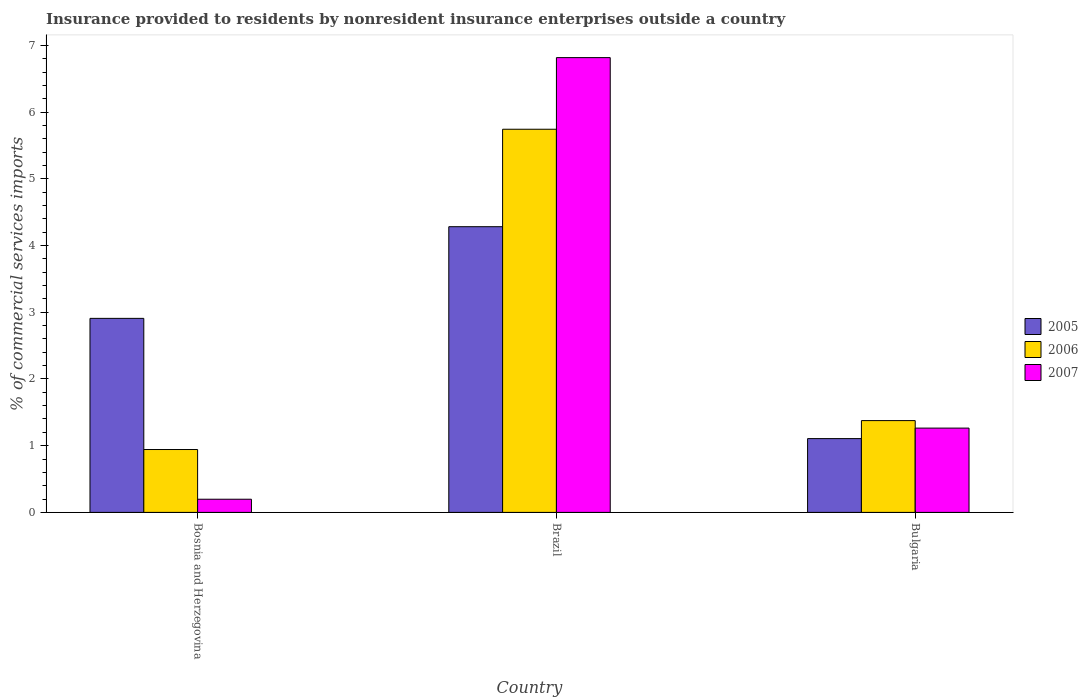How many different coloured bars are there?
Provide a succinct answer. 3. How many groups of bars are there?
Provide a succinct answer. 3. Are the number of bars on each tick of the X-axis equal?
Provide a short and direct response. Yes. How many bars are there on the 1st tick from the left?
Your answer should be very brief. 3. How many bars are there on the 3rd tick from the right?
Give a very brief answer. 3. What is the label of the 1st group of bars from the left?
Offer a terse response. Bosnia and Herzegovina. What is the Insurance provided to residents in 2005 in Brazil?
Offer a very short reply. 4.28. Across all countries, what is the maximum Insurance provided to residents in 2007?
Ensure brevity in your answer.  6.82. Across all countries, what is the minimum Insurance provided to residents in 2006?
Your response must be concise. 0.94. In which country was the Insurance provided to residents in 2005 minimum?
Offer a very short reply. Bulgaria. What is the total Insurance provided to residents in 2007 in the graph?
Offer a very short reply. 8.28. What is the difference between the Insurance provided to residents in 2005 in Brazil and that in Bulgaria?
Your response must be concise. 3.18. What is the difference between the Insurance provided to residents in 2006 in Bulgaria and the Insurance provided to residents in 2005 in Brazil?
Offer a terse response. -2.91. What is the average Insurance provided to residents in 2005 per country?
Keep it short and to the point. 2.77. What is the difference between the Insurance provided to residents of/in 2005 and Insurance provided to residents of/in 2007 in Bulgaria?
Your answer should be very brief. -0.16. In how many countries, is the Insurance provided to residents in 2006 greater than 0.4 %?
Keep it short and to the point. 3. What is the ratio of the Insurance provided to residents in 2006 in Bosnia and Herzegovina to that in Bulgaria?
Provide a succinct answer. 0.68. Is the difference between the Insurance provided to residents in 2005 in Bosnia and Herzegovina and Brazil greater than the difference between the Insurance provided to residents in 2007 in Bosnia and Herzegovina and Brazil?
Keep it short and to the point. Yes. What is the difference between the highest and the second highest Insurance provided to residents in 2005?
Offer a very short reply. -1.8. What is the difference between the highest and the lowest Insurance provided to residents in 2007?
Ensure brevity in your answer.  6.62. Is the sum of the Insurance provided to residents in 2007 in Bosnia and Herzegovina and Brazil greater than the maximum Insurance provided to residents in 2006 across all countries?
Ensure brevity in your answer.  Yes. What does the 3rd bar from the left in Bosnia and Herzegovina represents?
Your response must be concise. 2007. What does the 1st bar from the right in Bosnia and Herzegovina represents?
Your answer should be very brief. 2007. Is it the case that in every country, the sum of the Insurance provided to residents in 2005 and Insurance provided to residents in 2007 is greater than the Insurance provided to residents in 2006?
Offer a terse response. Yes. How many bars are there?
Make the answer very short. 9. What is the difference between two consecutive major ticks on the Y-axis?
Your response must be concise. 1. Does the graph contain any zero values?
Keep it short and to the point. No. How many legend labels are there?
Provide a short and direct response. 3. How are the legend labels stacked?
Give a very brief answer. Vertical. What is the title of the graph?
Your response must be concise. Insurance provided to residents by nonresident insurance enterprises outside a country. What is the label or title of the Y-axis?
Your response must be concise. % of commercial services imports. What is the % of commercial services imports in 2005 in Bosnia and Herzegovina?
Keep it short and to the point. 2.91. What is the % of commercial services imports in 2006 in Bosnia and Herzegovina?
Give a very brief answer. 0.94. What is the % of commercial services imports in 2007 in Bosnia and Herzegovina?
Make the answer very short. 0.2. What is the % of commercial services imports in 2005 in Brazil?
Your answer should be compact. 4.28. What is the % of commercial services imports in 2006 in Brazil?
Give a very brief answer. 5.74. What is the % of commercial services imports of 2007 in Brazil?
Offer a very short reply. 6.82. What is the % of commercial services imports in 2005 in Bulgaria?
Keep it short and to the point. 1.11. What is the % of commercial services imports in 2006 in Bulgaria?
Ensure brevity in your answer.  1.38. What is the % of commercial services imports of 2007 in Bulgaria?
Provide a short and direct response. 1.26. Across all countries, what is the maximum % of commercial services imports in 2005?
Offer a very short reply. 4.28. Across all countries, what is the maximum % of commercial services imports of 2006?
Your response must be concise. 5.74. Across all countries, what is the maximum % of commercial services imports in 2007?
Keep it short and to the point. 6.82. Across all countries, what is the minimum % of commercial services imports of 2005?
Provide a succinct answer. 1.11. Across all countries, what is the minimum % of commercial services imports in 2006?
Offer a very short reply. 0.94. Across all countries, what is the minimum % of commercial services imports in 2007?
Provide a succinct answer. 0.2. What is the total % of commercial services imports of 2005 in the graph?
Ensure brevity in your answer.  8.3. What is the total % of commercial services imports of 2006 in the graph?
Make the answer very short. 8.06. What is the total % of commercial services imports in 2007 in the graph?
Provide a succinct answer. 8.28. What is the difference between the % of commercial services imports in 2005 in Bosnia and Herzegovina and that in Brazil?
Keep it short and to the point. -1.37. What is the difference between the % of commercial services imports of 2006 in Bosnia and Herzegovina and that in Brazil?
Provide a short and direct response. -4.8. What is the difference between the % of commercial services imports of 2007 in Bosnia and Herzegovina and that in Brazil?
Offer a terse response. -6.62. What is the difference between the % of commercial services imports of 2005 in Bosnia and Herzegovina and that in Bulgaria?
Your answer should be very brief. 1.8. What is the difference between the % of commercial services imports in 2006 in Bosnia and Herzegovina and that in Bulgaria?
Provide a succinct answer. -0.43. What is the difference between the % of commercial services imports in 2007 in Bosnia and Herzegovina and that in Bulgaria?
Offer a terse response. -1.07. What is the difference between the % of commercial services imports of 2005 in Brazil and that in Bulgaria?
Your answer should be compact. 3.18. What is the difference between the % of commercial services imports of 2006 in Brazil and that in Bulgaria?
Give a very brief answer. 4.37. What is the difference between the % of commercial services imports in 2007 in Brazil and that in Bulgaria?
Provide a short and direct response. 5.55. What is the difference between the % of commercial services imports in 2005 in Bosnia and Herzegovina and the % of commercial services imports in 2006 in Brazil?
Keep it short and to the point. -2.83. What is the difference between the % of commercial services imports in 2005 in Bosnia and Herzegovina and the % of commercial services imports in 2007 in Brazil?
Make the answer very short. -3.91. What is the difference between the % of commercial services imports of 2006 in Bosnia and Herzegovina and the % of commercial services imports of 2007 in Brazil?
Provide a short and direct response. -5.87. What is the difference between the % of commercial services imports in 2005 in Bosnia and Herzegovina and the % of commercial services imports in 2006 in Bulgaria?
Provide a short and direct response. 1.53. What is the difference between the % of commercial services imports in 2005 in Bosnia and Herzegovina and the % of commercial services imports in 2007 in Bulgaria?
Make the answer very short. 1.64. What is the difference between the % of commercial services imports in 2006 in Bosnia and Herzegovina and the % of commercial services imports in 2007 in Bulgaria?
Offer a terse response. -0.32. What is the difference between the % of commercial services imports in 2005 in Brazil and the % of commercial services imports in 2006 in Bulgaria?
Ensure brevity in your answer.  2.91. What is the difference between the % of commercial services imports of 2005 in Brazil and the % of commercial services imports of 2007 in Bulgaria?
Make the answer very short. 3.02. What is the difference between the % of commercial services imports in 2006 in Brazil and the % of commercial services imports in 2007 in Bulgaria?
Offer a terse response. 4.48. What is the average % of commercial services imports in 2005 per country?
Provide a short and direct response. 2.77. What is the average % of commercial services imports in 2006 per country?
Your response must be concise. 2.69. What is the average % of commercial services imports of 2007 per country?
Provide a succinct answer. 2.76. What is the difference between the % of commercial services imports of 2005 and % of commercial services imports of 2006 in Bosnia and Herzegovina?
Make the answer very short. 1.97. What is the difference between the % of commercial services imports of 2005 and % of commercial services imports of 2007 in Bosnia and Herzegovina?
Offer a very short reply. 2.71. What is the difference between the % of commercial services imports in 2006 and % of commercial services imports in 2007 in Bosnia and Herzegovina?
Your answer should be compact. 0.74. What is the difference between the % of commercial services imports in 2005 and % of commercial services imports in 2006 in Brazil?
Provide a succinct answer. -1.46. What is the difference between the % of commercial services imports of 2005 and % of commercial services imports of 2007 in Brazil?
Keep it short and to the point. -2.53. What is the difference between the % of commercial services imports of 2006 and % of commercial services imports of 2007 in Brazil?
Offer a terse response. -1.07. What is the difference between the % of commercial services imports of 2005 and % of commercial services imports of 2006 in Bulgaria?
Your answer should be compact. -0.27. What is the difference between the % of commercial services imports in 2005 and % of commercial services imports in 2007 in Bulgaria?
Offer a very short reply. -0.16. What is the difference between the % of commercial services imports in 2006 and % of commercial services imports in 2007 in Bulgaria?
Make the answer very short. 0.11. What is the ratio of the % of commercial services imports in 2005 in Bosnia and Herzegovina to that in Brazil?
Provide a short and direct response. 0.68. What is the ratio of the % of commercial services imports in 2006 in Bosnia and Herzegovina to that in Brazil?
Keep it short and to the point. 0.16. What is the ratio of the % of commercial services imports in 2007 in Bosnia and Herzegovina to that in Brazil?
Your answer should be compact. 0.03. What is the ratio of the % of commercial services imports of 2005 in Bosnia and Herzegovina to that in Bulgaria?
Provide a short and direct response. 2.63. What is the ratio of the % of commercial services imports in 2006 in Bosnia and Herzegovina to that in Bulgaria?
Your answer should be very brief. 0.68. What is the ratio of the % of commercial services imports in 2007 in Bosnia and Herzegovina to that in Bulgaria?
Provide a short and direct response. 0.16. What is the ratio of the % of commercial services imports in 2005 in Brazil to that in Bulgaria?
Make the answer very short. 3.87. What is the ratio of the % of commercial services imports in 2006 in Brazil to that in Bulgaria?
Keep it short and to the point. 4.17. What is the ratio of the % of commercial services imports in 2007 in Brazil to that in Bulgaria?
Make the answer very short. 5.39. What is the difference between the highest and the second highest % of commercial services imports of 2005?
Make the answer very short. 1.37. What is the difference between the highest and the second highest % of commercial services imports in 2006?
Provide a short and direct response. 4.37. What is the difference between the highest and the second highest % of commercial services imports in 2007?
Ensure brevity in your answer.  5.55. What is the difference between the highest and the lowest % of commercial services imports in 2005?
Keep it short and to the point. 3.18. What is the difference between the highest and the lowest % of commercial services imports of 2006?
Offer a terse response. 4.8. What is the difference between the highest and the lowest % of commercial services imports in 2007?
Offer a very short reply. 6.62. 